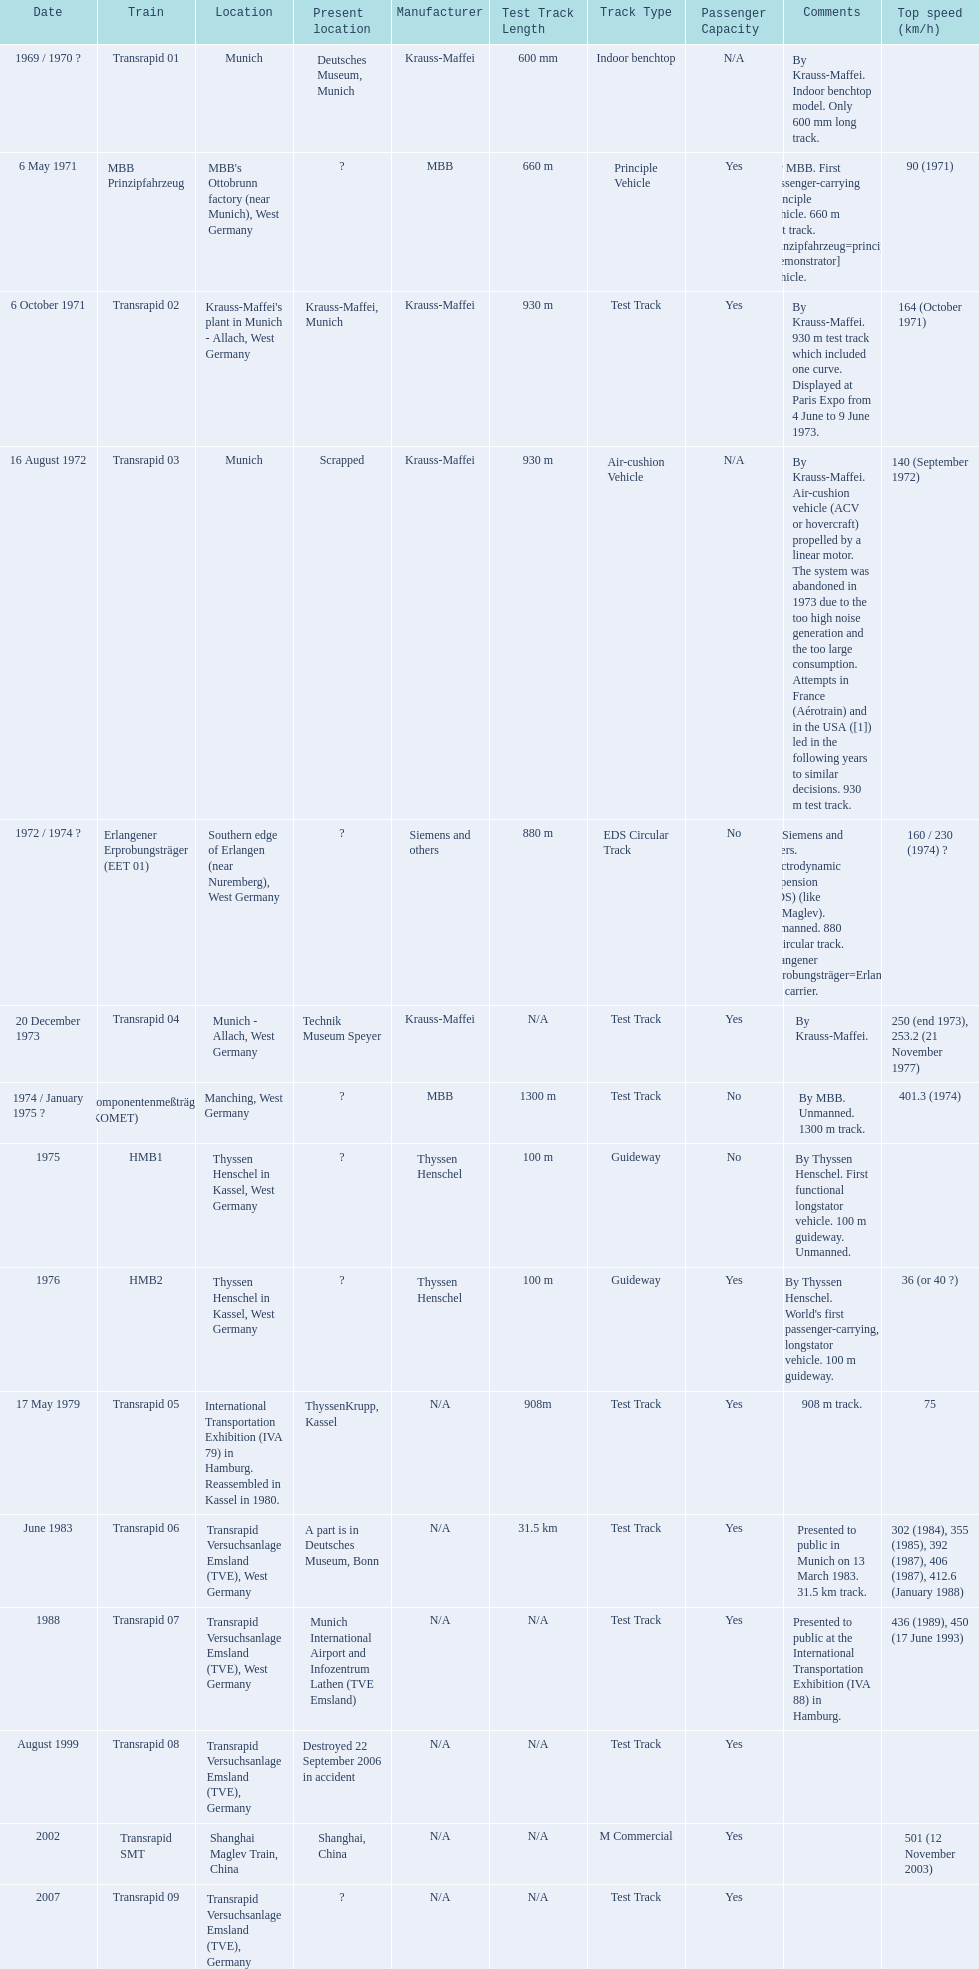How many trains listed have the same speed as the hmb2? 0. 